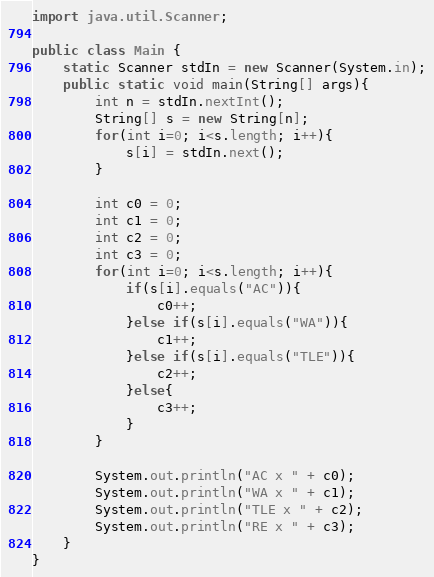<code> <loc_0><loc_0><loc_500><loc_500><_Java_>import java.util.Scanner;

public class Main {
    static Scanner stdIn = new Scanner(System.in);
    public static void main(String[] args){
        int n = stdIn.nextInt();
        String[] s = new String[n];
        for(int i=0; i<s.length; i++){
            s[i] = stdIn.next();
        }

        int c0 = 0;
        int c1 = 0;
        int c2 = 0;
        int c3 = 0;
        for(int i=0; i<s.length; i++){
            if(s[i].equals("AC")){
                c0++;
            }else if(s[i].equals("WA")){
                c1++;
            }else if(s[i].equals("TLE")){
                c2++;
            }else{
                c3++;
            }
        }

        System.out.println("AC x " + c0);
        System.out.println("WA x " + c1);
        System.out.println("TLE x " + c2);
        System.out.println("RE x " + c3);
    }
}
</code> 